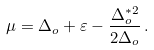Convert formula to latex. <formula><loc_0><loc_0><loc_500><loc_500>\mu = \Delta _ { o } + \varepsilon - \frac { \Delta _ { o } ^ { * 2 } } { 2 \Delta _ { o } } \, .</formula> 